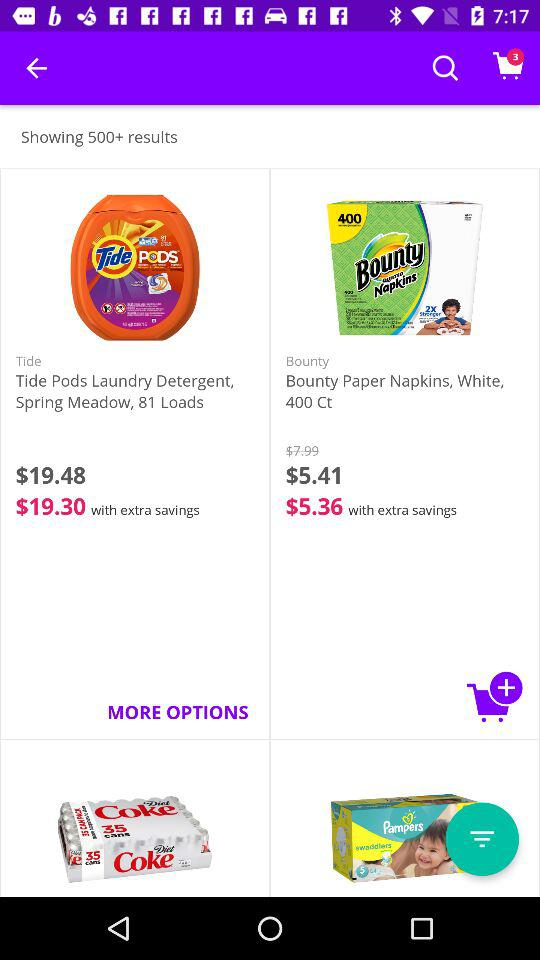What is the price of "Tide Pods Laundry Detergent" before saving? The price before savings is $19.48. 